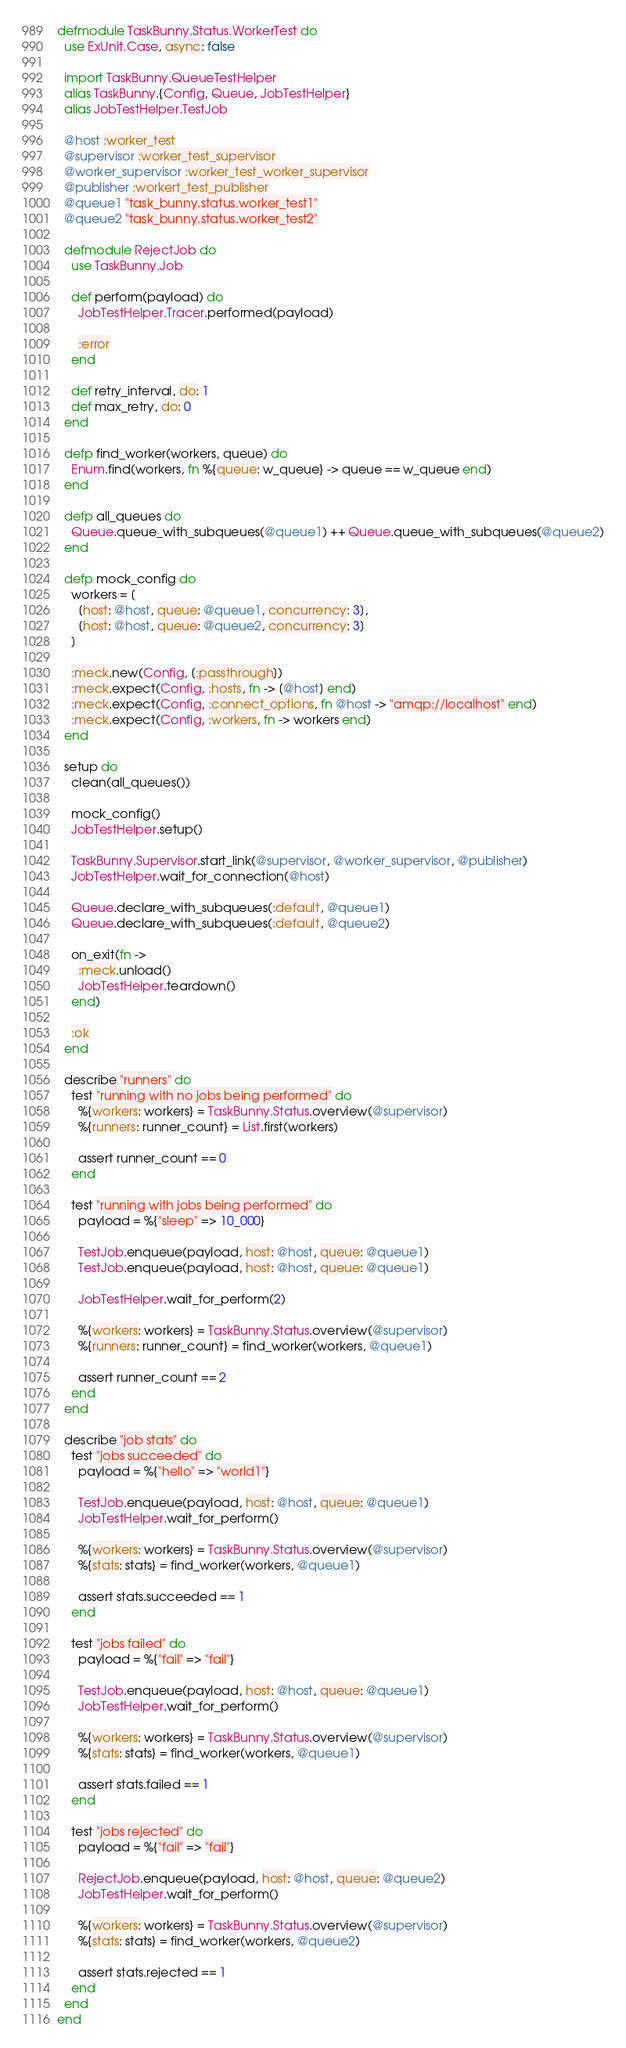<code> <loc_0><loc_0><loc_500><loc_500><_Elixir_>defmodule TaskBunny.Status.WorkerTest do
  use ExUnit.Case, async: false

  import TaskBunny.QueueTestHelper
  alias TaskBunny.{Config, Queue, JobTestHelper}
  alias JobTestHelper.TestJob

  @host :worker_test
  @supervisor :worker_test_supervisor
  @worker_supervisor :worker_test_worker_supervisor
  @publisher :workert_test_publisher
  @queue1 "task_bunny.status.worker_test1"
  @queue2 "task_bunny.status.worker_test2"

  defmodule RejectJob do
    use TaskBunny.Job

    def perform(payload) do
      JobTestHelper.Tracer.performed(payload)

      :error
    end

    def retry_interval, do: 1
    def max_retry, do: 0
  end

  defp find_worker(workers, queue) do
    Enum.find(workers, fn %{queue: w_queue} -> queue == w_queue end)
  end

  defp all_queues do
    Queue.queue_with_subqueues(@queue1) ++ Queue.queue_with_subqueues(@queue2)
  end

  defp mock_config do
    workers = [
      [host: @host, queue: @queue1, concurrency: 3],
      [host: @host, queue: @queue2, concurrency: 3]
    ]

    :meck.new(Config, [:passthrough])
    :meck.expect(Config, :hosts, fn -> [@host] end)
    :meck.expect(Config, :connect_options, fn @host -> "amqp://localhost" end)
    :meck.expect(Config, :workers, fn -> workers end)
  end

  setup do
    clean(all_queues())

    mock_config()
    JobTestHelper.setup()

    TaskBunny.Supervisor.start_link(@supervisor, @worker_supervisor, @publisher)
    JobTestHelper.wait_for_connection(@host)

    Queue.declare_with_subqueues(:default, @queue1)
    Queue.declare_with_subqueues(:default, @queue2)

    on_exit(fn ->
      :meck.unload()
      JobTestHelper.teardown()
    end)

    :ok
  end

  describe "runners" do
    test "running with no jobs being performed" do
      %{workers: workers} = TaskBunny.Status.overview(@supervisor)
      %{runners: runner_count} = List.first(workers)

      assert runner_count == 0
    end

    test "running with jobs being performed" do
      payload = %{"sleep" => 10_000}

      TestJob.enqueue(payload, host: @host, queue: @queue1)
      TestJob.enqueue(payload, host: @host, queue: @queue1)

      JobTestHelper.wait_for_perform(2)

      %{workers: workers} = TaskBunny.Status.overview(@supervisor)
      %{runners: runner_count} = find_worker(workers, @queue1)

      assert runner_count == 2
    end
  end

  describe "job stats" do
    test "jobs succeeded" do
      payload = %{"hello" => "world1"}

      TestJob.enqueue(payload, host: @host, queue: @queue1)
      JobTestHelper.wait_for_perform()

      %{workers: workers} = TaskBunny.Status.overview(@supervisor)
      %{stats: stats} = find_worker(workers, @queue1)

      assert stats.succeeded == 1
    end

    test "jobs failed" do
      payload = %{"fail" => "fail"}

      TestJob.enqueue(payload, host: @host, queue: @queue1)
      JobTestHelper.wait_for_perform()

      %{workers: workers} = TaskBunny.Status.overview(@supervisor)
      %{stats: stats} = find_worker(workers, @queue1)

      assert stats.failed == 1
    end

    test "jobs rejected" do
      payload = %{"fail" => "fail"}

      RejectJob.enqueue(payload, host: @host, queue: @queue2)
      JobTestHelper.wait_for_perform()

      %{workers: workers} = TaskBunny.Status.overview(@supervisor)
      %{stats: stats} = find_worker(workers, @queue2)

      assert stats.rejected == 1
    end
  end
end
</code> 